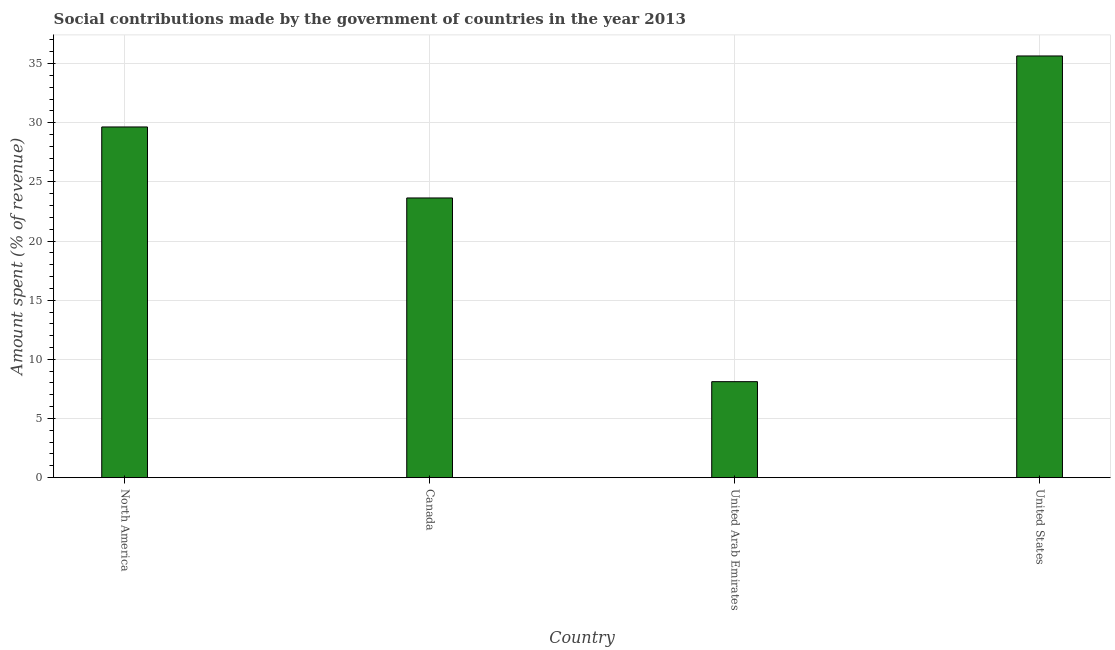Does the graph contain any zero values?
Make the answer very short. No. Does the graph contain grids?
Your answer should be very brief. Yes. What is the title of the graph?
Provide a succinct answer. Social contributions made by the government of countries in the year 2013. What is the label or title of the X-axis?
Offer a terse response. Country. What is the label or title of the Y-axis?
Offer a very short reply. Amount spent (% of revenue). What is the amount spent in making social contributions in Canada?
Your answer should be very brief. 23.64. Across all countries, what is the maximum amount spent in making social contributions?
Your answer should be compact. 35.64. Across all countries, what is the minimum amount spent in making social contributions?
Keep it short and to the point. 8.11. In which country was the amount spent in making social contributions minimum?
Your response must be concise. United Arab Emirates. What is the sum of the amount spent in making social contributions?
Ensure brevity in your answer.  97.04. What is the difference between the amount spent in making social contributions in Canada and United States?
Your answer should be compact. -12. What is the average amount spent in making social contributions per country?
Provide a short and direct response. 24.26. What is the median amount spent in making social contributions?
Provide a succinct answer. 26.64. What is the ratio of the amount spent in making social contributions in United Arab Emirates to that in United States?
Provide a short and direct response. 0.23. Is the difference between the amount spent in making social contributions in North America and United Arab Emirates greater than the difference between any two countries?
Your response must be concise. No. What is the difference between the highest and the second highest amount spent in making social contributions?
Your response must be concise. 6. What is the difference between the highest and the lowest amount spent in making social contributions?
Offer a very short reply. 27.53. How many countries are there in the graph?
Provide a short and direct response. 4. Are the values on the major ticks of Y-axis written in scientific E-notation?
Keep it short and to the point. No. What is the Amount spent (% of revenue) of North America?
Your response must be concise. 29.64. What is the Amount spent (% of revenue) of Canada?
Ensure brevity in your answer.  23.64. What is the Amount spent (% of revenue) of United Arab Emirates?
Ensure brevity in your answer.  8.11. What is the Amount spent (% of revenue) in United States?
Make the answer very short. 35.64. What is the difference between the Amount spent (% of revenue) in North America and Canada?
Give a very brief answer. 6. What is the difference between the Amount spent (% of revenue) in North America and United Arab Emirates?
Your answer should be very brief. 21.53. What is the difference between the Amount spent (% of revenue) in North America and United States?
Keep it short and to the point. -6. What is the difference between the Amount spent (% of revenue) in Canada and United Arab Emirates?
Provide a short and direct response. 15.53. What is the difference between the Amount spent (% of revenue) in Canada and United States?
Make the answer very short. -12. What is the difference between the Amount spent (% of revenue) in United Arab Emirates and United States?
Provide a succinct answer. -27.53. What is the ratio of the Amount spent (% of revenue) in North America to that in Canada?
Provide a succinct answer. 1.25. What is the ratio of the Amount spent (% of revenue) in North America to that in United Arab Emirates?
Provide a succinct answer. 3.65. What is the ratio of the Amount spent (% of revenue) in North America to that in United States?
Your response must be concise. 0.83. What is the ratio of the Amount spent (% of revenue) in Canada to that in United Arab Emirates?
Your response must be concise. 2.91. What is the ratio of the Amount spent (% of revenue) in Canada to that in United States?
Your response must be concise. 0.66. What is the ratio of the Amount spent (% of revenue) in United Arab Emirates to that in United States?
Keep it short and to the point. 0.23. 